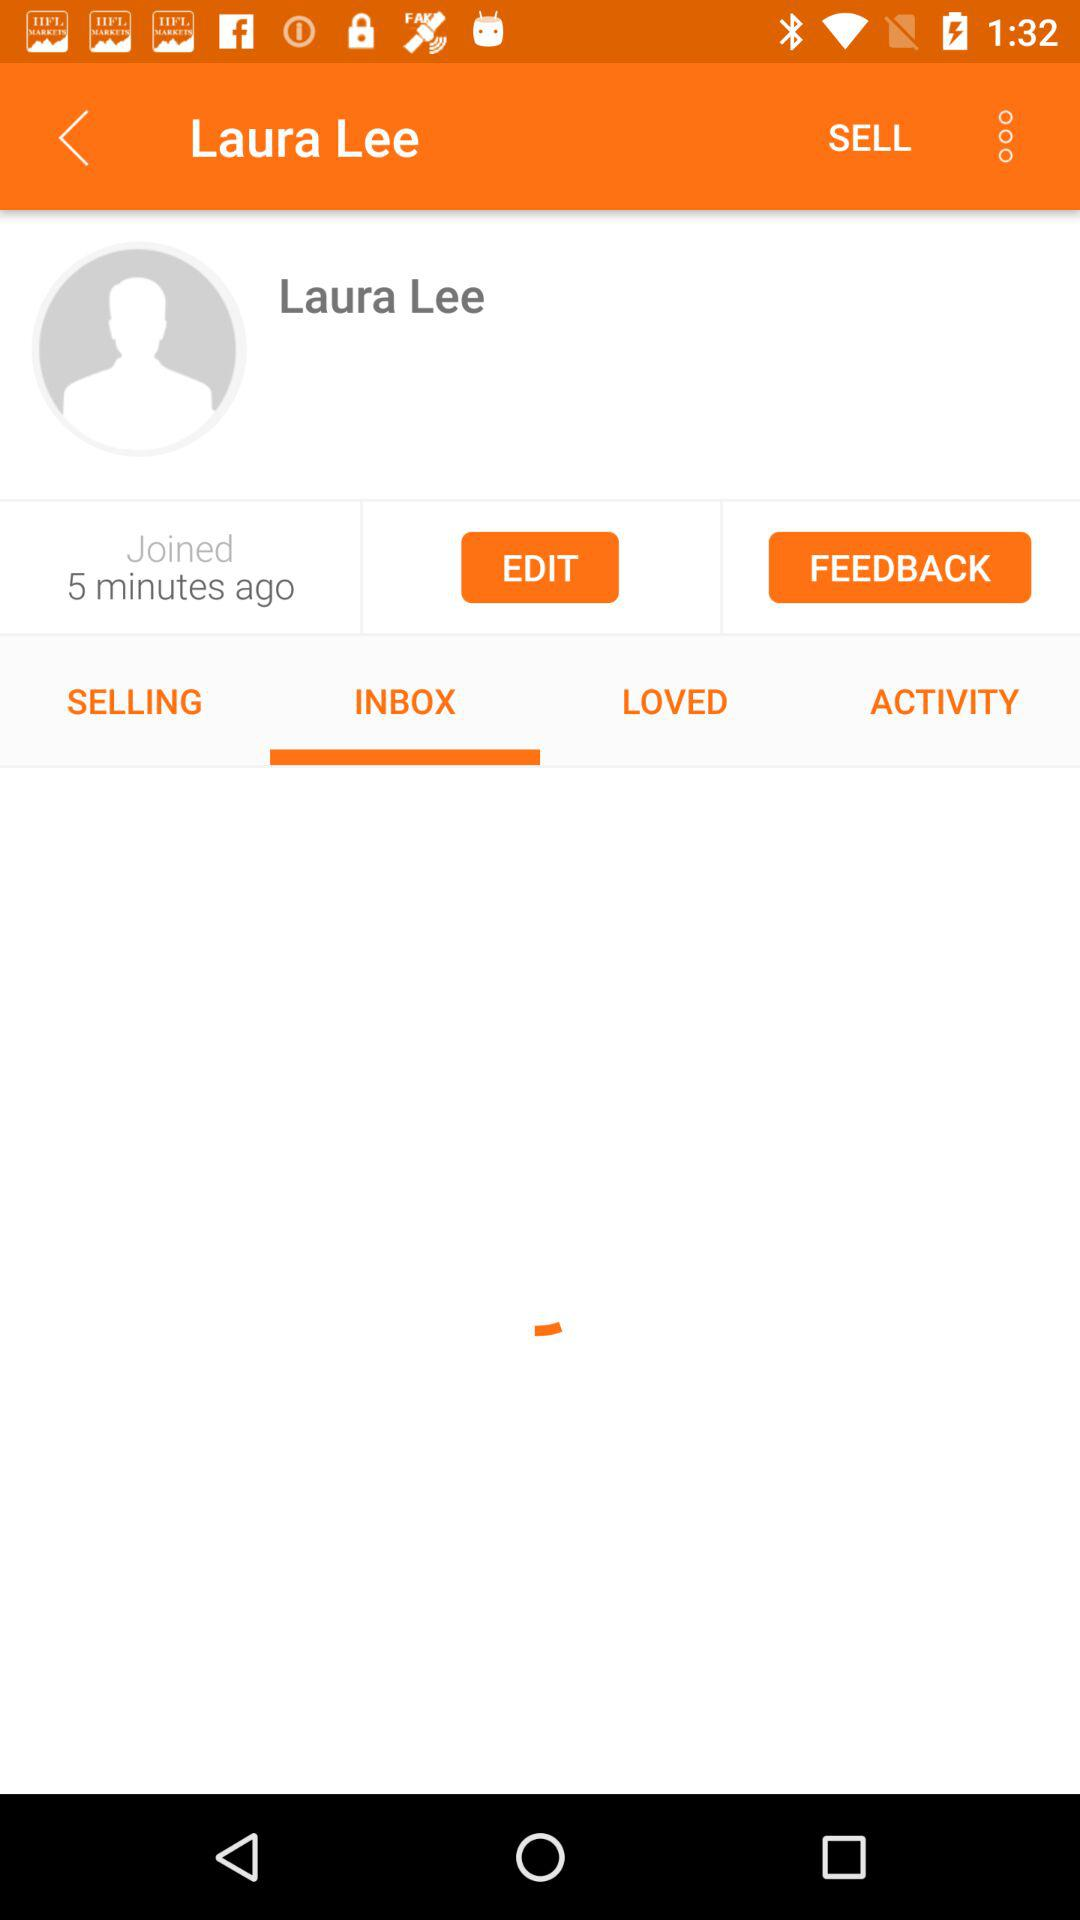Which tab has been selected? The selected tab is "INBOX". 